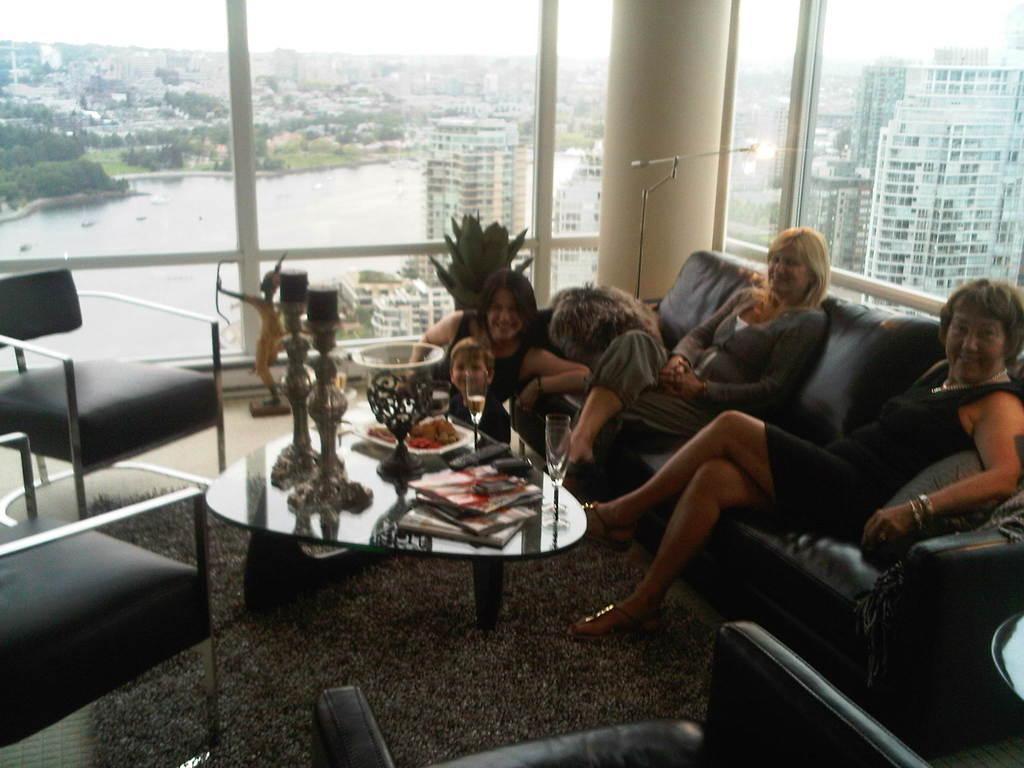In one or two sentences, can you explain what this image depicts? In this image there are three woman who are sitting on the right side there are two women sitting on a couch beside them there is another women who is sitting and smiling in front of her there is one boy. On the left side there are two chairs and in the middle there is one table and on that table there are some books remote and statues are there and on the floor there is one carpet and in the background there are glass doors and some trees and buildings are there. 